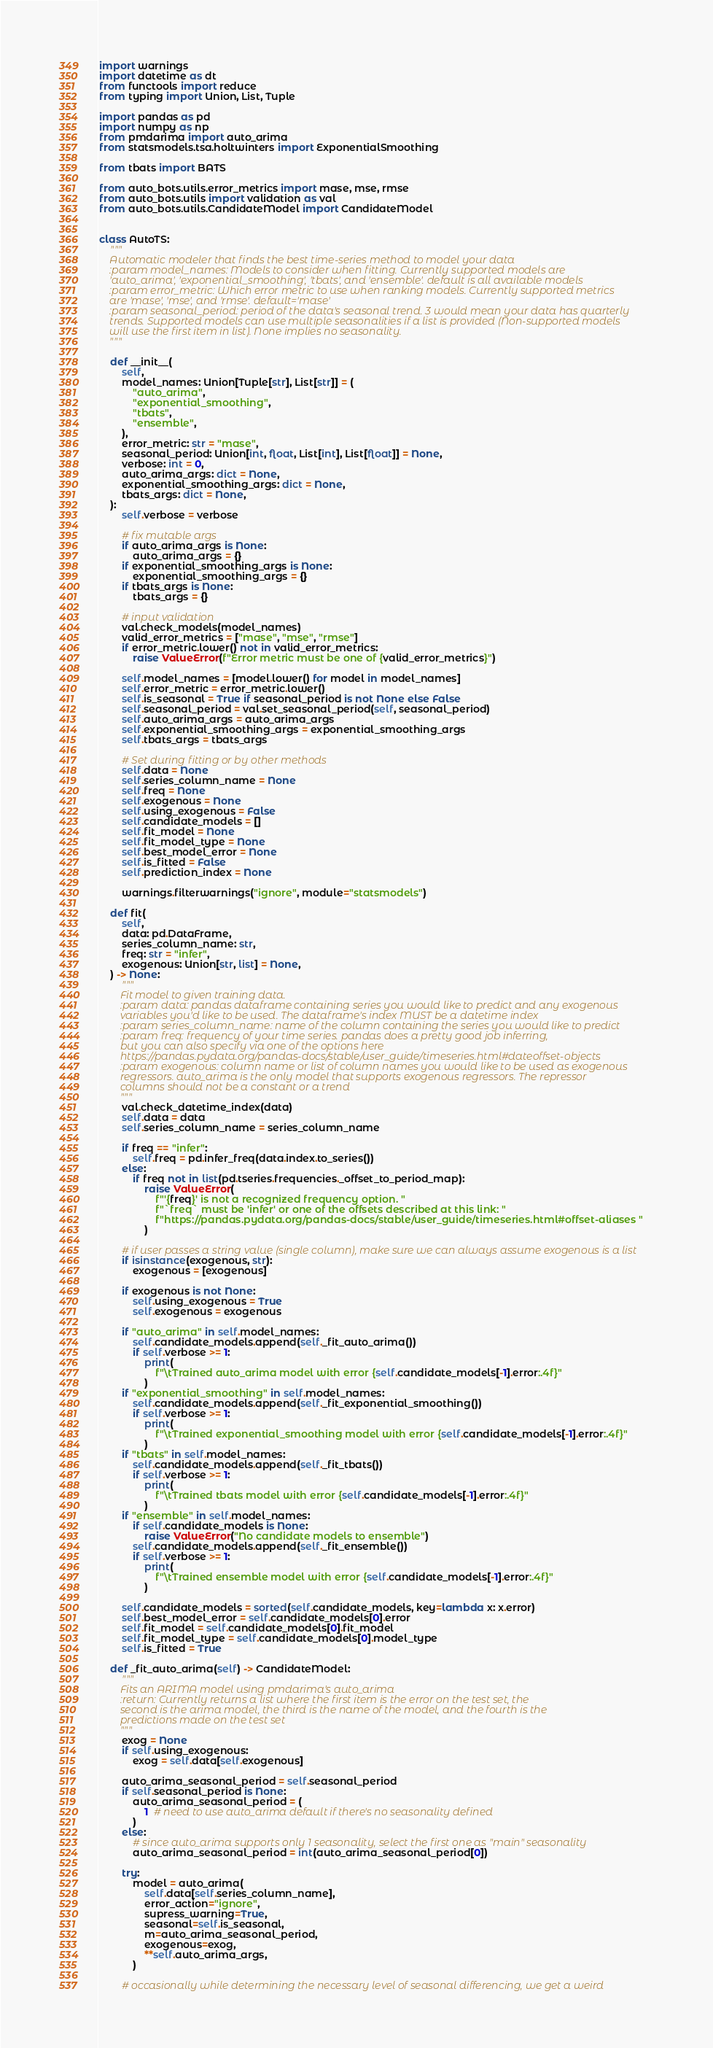Convert code to text. <code><loc_0><loc_0><loc_500><loc_500><_Python_>import warnings
import datetime as dt
from functools import reduce
from typing import Union, List, Tuple

import pandas as pd
import numpy as np
from pmdarima import auto_arima
from statsmodels.tsa.holtwinters import ExponentialSmoothing

from tbats import BATS

from auto_bots.utils.error_metrics import mase, mse, rmse
from auto_bots.utils import validation as val
from auto_bots.utils.CandidateModel import CandidateModel


class AutoTS:
    """
    Automatic modeler that finds the best time-series method to model your data
    :param model_names: Models to consider when fitting. Currently supported models are
    'auto_arima', 'exponential_smoothing', 'tbats', and 'ensemble'. default is all available models
    :param error_metric: Which error metric to use when ranking models. Currently supported metrics
    are 'mase', 'mse', and 'rmse'. default='mase'
    :param seasonal_period: period of the data's seasonal trend. 3 would mean your data has quarterly
    trends. Supported models can use multiple seasonalities if a list is provided (Non-supported models
    will use the first item in list). None implies no seasonality.
    """

    def __init__(
        self,
        model_names: Union[Tuple[str], List[str]] = (
            "auto_arima",
            "exponential_smoothing",
            "tbats",
            "ensemble",
        ),
        error_metric: str = "mase",
        seasonal_period: Union[int, float, List[int], List[float]] = None,
        verbose: int = 0,
        auto_arima_args: dict = None,
        exponential_smoothing_args: dict = None,
        tbats_args: dict = None,
    ):
        self.verbose = verbose

        # fix mutable args
        if auto_arima_args is None:
            auto_arima_args = {}
        if exponential_smoothing_args is None:
            exponential_smoothing_args = {}
        if tbats_args is None:
            tbats_args = {}

        # input validation
        val.check_models(model_names)
        valid_error_metrics = ["mase", "mse", "rmse"]
        if error_metric.lower() not in valid_error_metrics:
            raise ValueError(f"Error metric must be one of {valid_error_metrics}")

        self.model_names = [model.lower() for model in model_names]
        self.error_metric = error_metric.lower()
        self.is_seasonal = True if seasonal_period is not None else False
        self.seasonal_period = val.set_seasonal_period(self, seasonal_period)
        self.auto_arima_args = auto_arima_args
        self.exponential_smoothing_args = exponential_smoothing_args
        self.tbats_args = tbats_args

        # Set during fitting or by other methods
        self.data = None
        self.series_column_name = None
        self.freq = None
        self.exogenous = None
        self.using_exogenous = False
        self.candidate_models = []
        self.fit_model = None
        self.fit_model_type = None
        self.best_model_error = None
        self.is_fitted = False
        self.prediction_index = None

        warnings.filterwarnings("ignore", module="statsmodels")

    def fit(
        self,
        data: pd.DataFrame,
        series_column_name: str,
        freq: str = "infer",
        exogenous: Union[str, list] = None,
    ) -> None:
        """
        Fit model to given training data.
        :param data: pandas dataframe containing series you would like to predict and any exogenous
        variables you'd like to be used. The dataframe's index MUST be a datetime index
        :param series_column_name: name of the column containing the series you would like to predict
        :param freq: frequency of your time series. pandas does a pretty good job inferring,
        but you can also specify via one of the options here
        https://pandas.pydata.org/pandas-docs/stable/user_guide/timeseries.html#dateoffset-objects
        :param exogenous: column name or list of column names you would like to be used as exogenous
        regressors. auto_arima is the only model that supports exogenous regressors. The repressor
        columns should not be a constant or a trend
        """
        val.check_datetime_index(data)
        self.data = data
        self.series_column_name = series_column_name

        if freq == "infer":
            self.freq = pd.infer_freq(data.index.to_series())
        else:
            if freq not in list(pd.tseries.frequencies._offset_to_period_map):
                raise ValueError(
                    f"'{freq}' is not a recognized frequency option. "
                    f"`freq` must be 'infer' or one of the offsets described at this link: "
                    f"https://pandas.pydata.org/pandas-docs/stable/user_guide/timeseries.html#offset-aliases "
                )

        # if user passes a string value (single column), make sure we can always assume exogenous is a list
        if isinstance(exogenous, str):
            exogenous = [exogenous]

        if exogenous is not None:
            self.using_exogenous = True
            self.exogenous = exogenous

        if "auto_arima" in self.model_names:
            self.candidate_models.append(self._fit_auto_arima())
            if self.verbose >= 1:
                print(
                    f"\tTrained auto_arima model with error {self.candidate_models[-1].error:.4f}"
                )
        if "exponential_smoothing" in self.model_names:
            self.candidate_models.append(self._fit_exponential_smoothing())
            if self.verbose >= 1:
                print(
                    f"\tTrained exponential_smoothing model with error {self.candidate_models[-1].error:.4f}"
                )
        if "tbats" in self.model_names:
            self.candidate_models.append(self._fit_tbats())
            if self.verbose >= 1:
                print(
                    f"\tTrained tbats model with error {self.candidate_models[-1].error:.4f}"
                )
        if "ensemble" in self.model_names:
            if self.candidate_models is None:
                raise ValueError("No candidate models to ensemble")
            self.candidate_models.append(self._fit_ensemble())
            if self.verbose >= 1:
                print(
                    f"\tTrained ensemble model with error {self.candidate_models[-1].error:.4f}"
                )

        self.candidate_models = sorted(self.candidate_models, key=lambda x: x.error)
        self.best_model_error = self.candidate_models[0].error
        self.fit_model = self.candidate_models[0].fit_model
        self.fit_model_type = self.candidate_models[0].model_type
        self.is_fitted = True

    def _fit_auto_arima(self) -> CandidateModel:
        """
        Fits an ARIMA model using pmdarima's auto_arima
        :return: Currently returns a list where the first item is the error on the test set, the
        second is the arima model, the third is the name of the model, and the fourth is the
        predictions made on the test set
        """
        exog = None
        if self.using_exogenous:
            exog = self.data[self.exogenous]

        auto_arima_seasonal_period = self.seasonal_period
        if self.seasonal_period is None:
            auto_arima_seasonal_period = (
                1  # need to use auto_arima default if there's no seasonality defined
            )
        else:
            # since auto_arima supports only 1 seasonality, select the first one as "main" seasonality
            auto_arima_seasonal_period = int(auto_arima_seasonal_period[0])

        try:
            model = auto_arima(
                self.data[self.series_column_name],
                error_action="ignore",
                supress_warning=True,
                seasonal=self.is_seasonal,
                m=auto_arima_seasonal_period,
                exogenous=exog,
                **self.auto_arima_args,
            )

        # occasionally while determining the necessary level of seasonal differencing, we get a weird</code> 